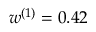Convert formula to latex. <formula><loc_0><loc_0><loc_500><loc_500>{ w ^ { ( 1 ) } = 0 . 4 2 }</formula> 